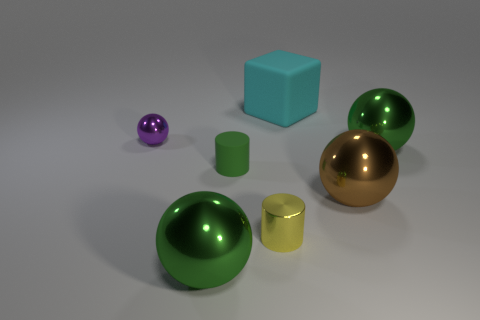There is a tiny green object that is the same shape as the tiny yellow shiny object; what is it made of?
Your answer should be compact. Rubber. There is a small rubber thing; does it have the same shape as the small metallic object left of the tiny green cylinder?
Your answer should be compact. No. What is the color of the big object that is right of the large cyan rubber object and behind the brown sphere?
Your answer should be compact. Green. Are any yellow matte cylinders visible?
Your answer should be compact. No. Are there the same number of purple things on the right side of the large brown metallic ball and tiny green objects?
Provide a short and direct response. No. How many other things are there of the same shape as the big brown object?
Your answer should be very brief. 3. What is the shape of the yellow object?
Keep it short and to the point. Cylinder. Do the green cylinder and the brown ball have the same material?
Offer a terse response. No. Is the number of brown shiny balls right of the brown ball the same as the number of tiny rubber cylinders that are in front of the small purple shiny ball?
Ensure brevity in your answer.  No. Are there any rubber things right of the object that is behind the tiny metal thing that is behind the large brown object?
Keep it short and to the point. No. 